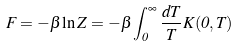<formula> <loc_0><loc_0><loc_500><loc_500>F = - \beta \ln Z = - \beta \int _ { 0 } ^ { \infty } \frac { d T } { T } K ( 0 , T )</formula> 